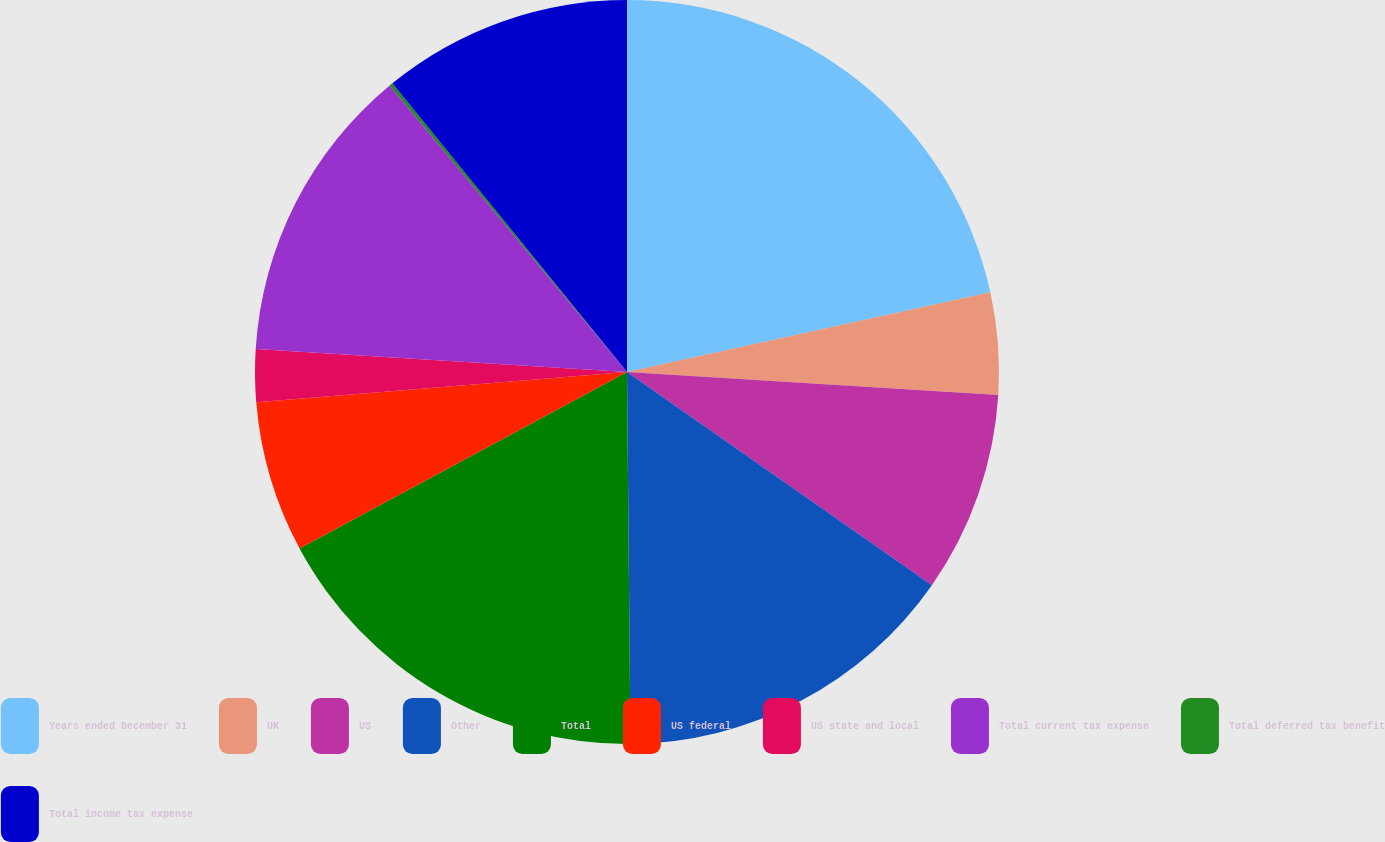Convert chart. <chart><loc_0><loc_0><loc_500><loc_500><pie_chart><fcel>Years ended December 31<fcel>UK<fcel>US<fcel>Other<fcel>Total<fcel>US federal<fcel>US state and local<fcel>Total current tax expense<fcel>Total deferred tax benefit<fcel>Total income tax expense<nl><fcel>21.56%<fcel>4.43%<fcel>8.72%<fcel>15.14%<fcel>17.28%<fcel>6.57%<fcel>2.29%<fcel>13.0%<fcel>0.15%<fcel>10.86%<nl></chart> 